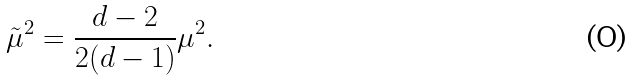Convert formula to latex. <formula><loc_0><loc_0><loc_500><loc_500>\tilde { \mu } ^ { 2 } = \frac { d - 2 } { 2 ( d - 1 ) } \mu ^ { 2 } .</formula> 